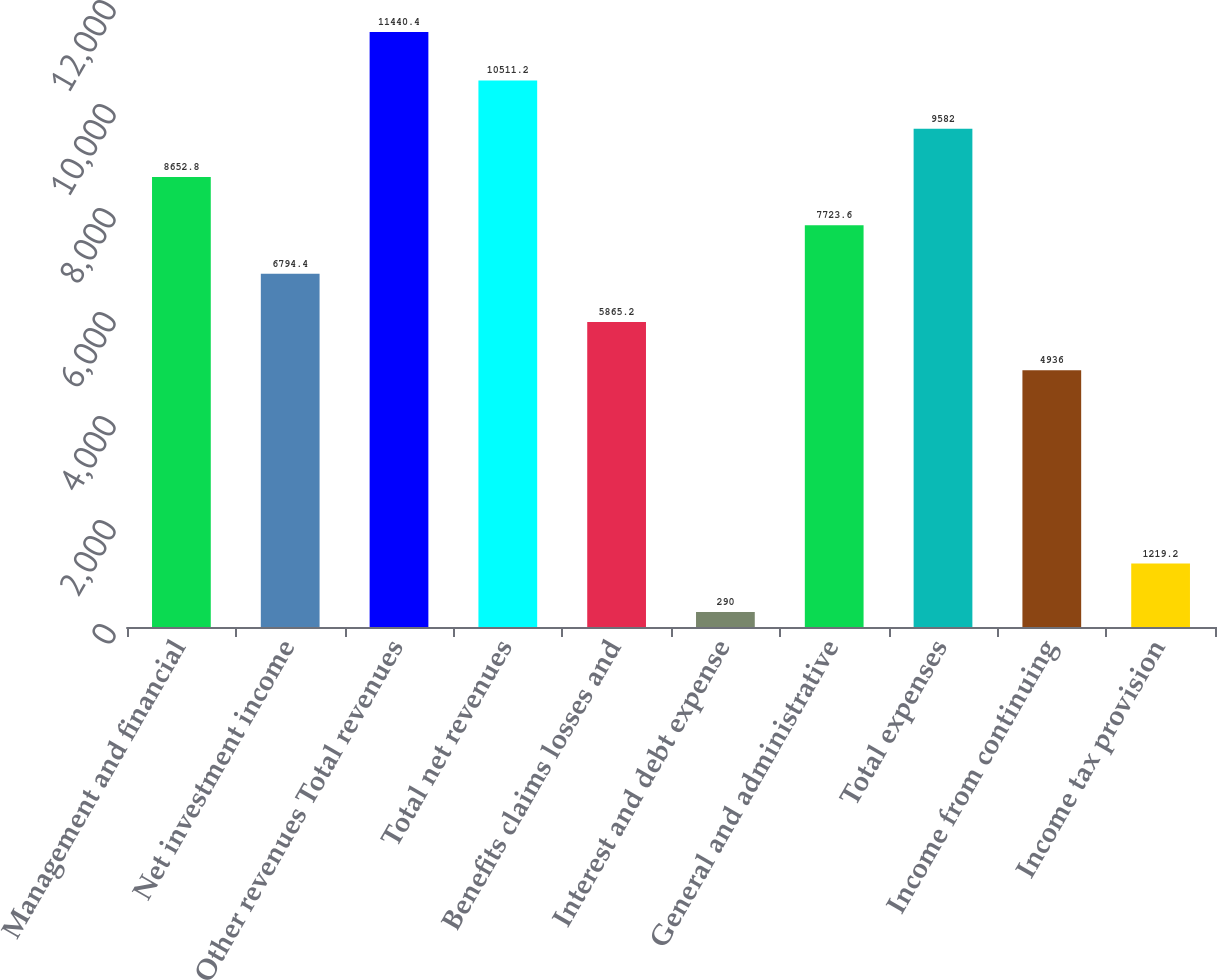Convert chart. <chart><loc_0><loc_0><loc_500><loc_500><bar_chart><fcel>Management and financial<fcel>Net investment income<fcel>Other revenues Total revenues<fcel>Total net revenues<fcel>Benefits claims losses and<fcel>Interest and debt expense<fcel>General and administrative<fcel>Total expenses<fcel>Income from continuing<fcel>Income tax provision<nl><fcel>8652.8<fcel>6794.4<fcel>11440.4<fcel>10511.2<fcel>5865.2<fcel>290<fcel>7723.6<fcel>9582<fcel>4936<fcel>1219.2<nl></chart> 